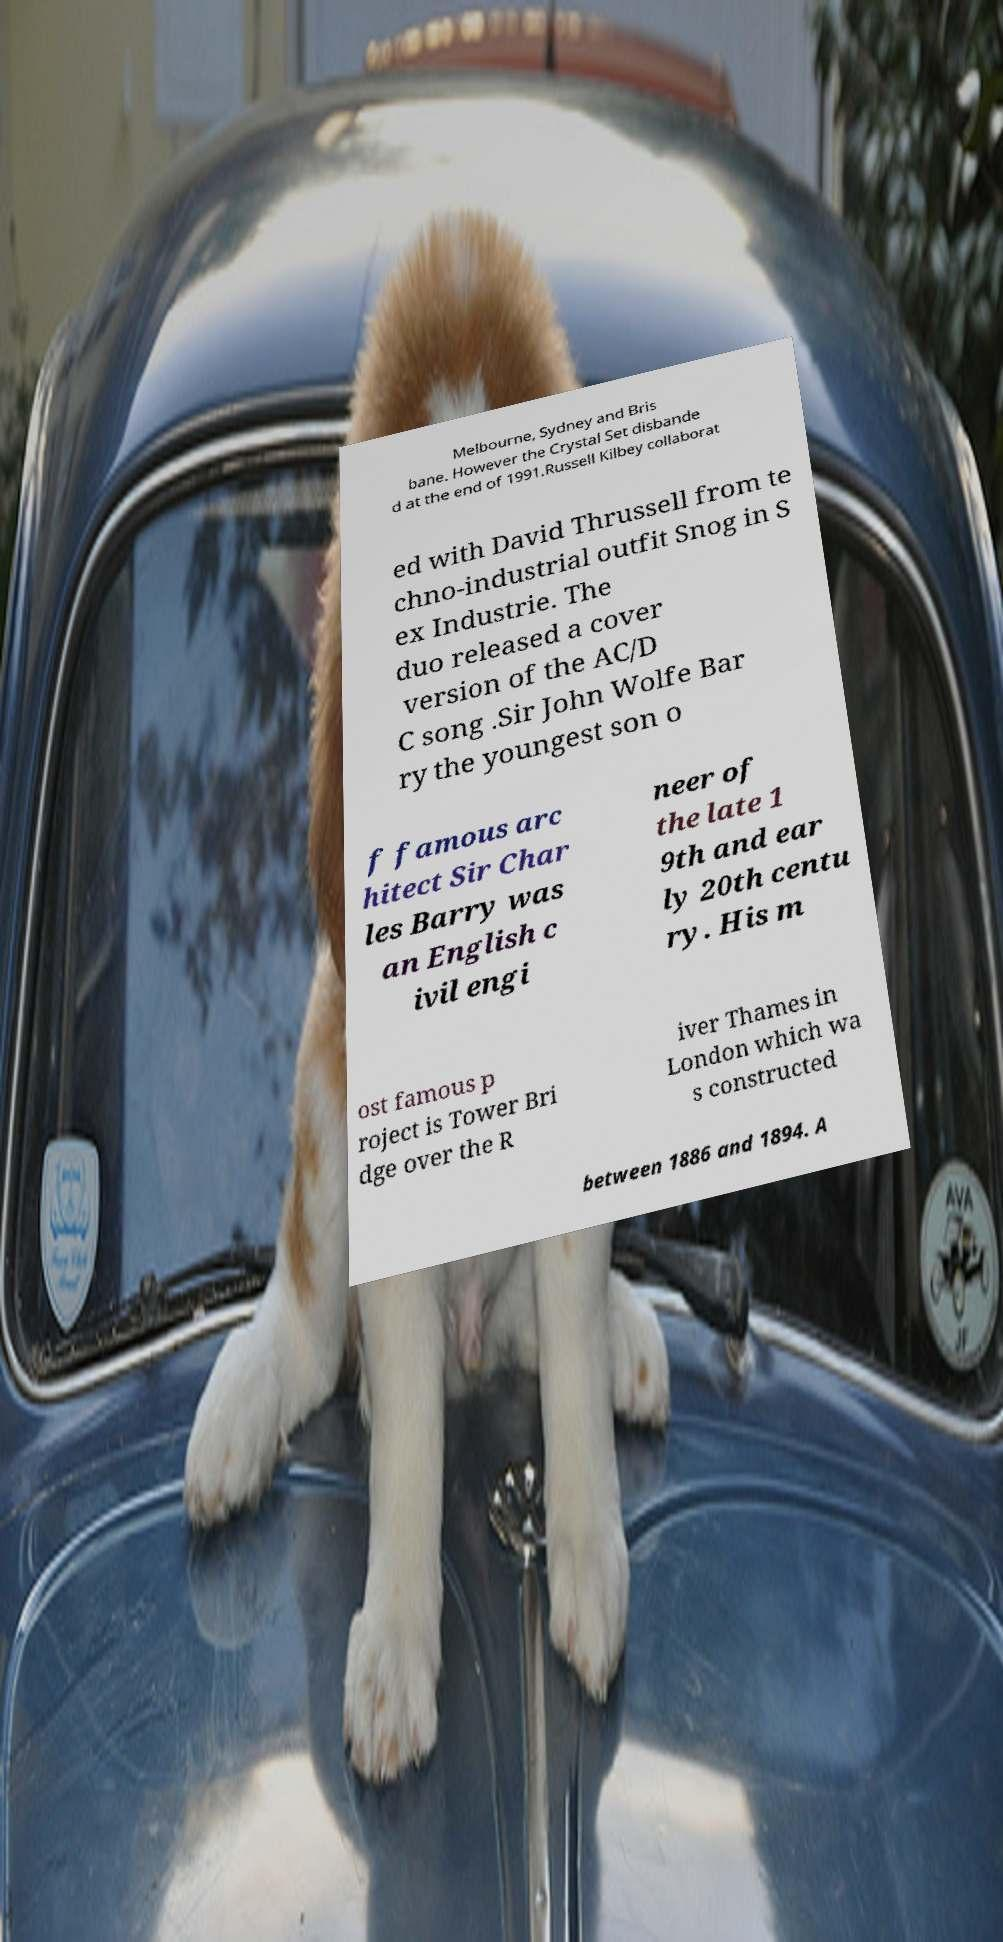There's text embedded in this image that I need extracted. Can you transcribe it verbatim? Melbourne, Sydney and Bris bane. However the Crystal Set disbande d at the end of 1991.Russell Kilbey collaborat ed with David Thrussell from te chno-industrial outfit Snog in S ex Industrie. The duo released a cover version of the AC/D C song .Sir John Wolfe Bar ry the youngest son o f famous arc hitect Sir Char les Barry was an English c ivil engi neer of the late 1 9th and ear ly 20th centu ry. His m ost famous p roject is Tower Bri dge over the R iver Thames in London which wa s constructed between 1886 and 1894. A 